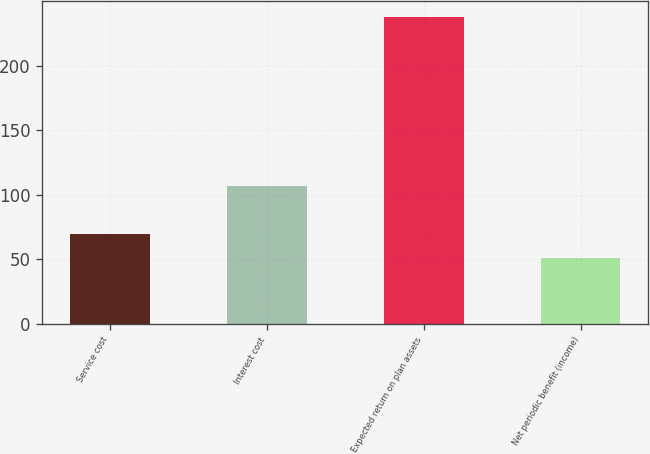Convert chart. <chart><loc_0><loc_0><loc_500><loc_500><bar_chart><fcel>Service cost<fcel>Interest cost<fcel>Expected return on plan assets<fcel>Net periodic benefit (income)<nl><fcel>69.7<fcel>107.1<fcel>238<fcel>51<nl></chart> 